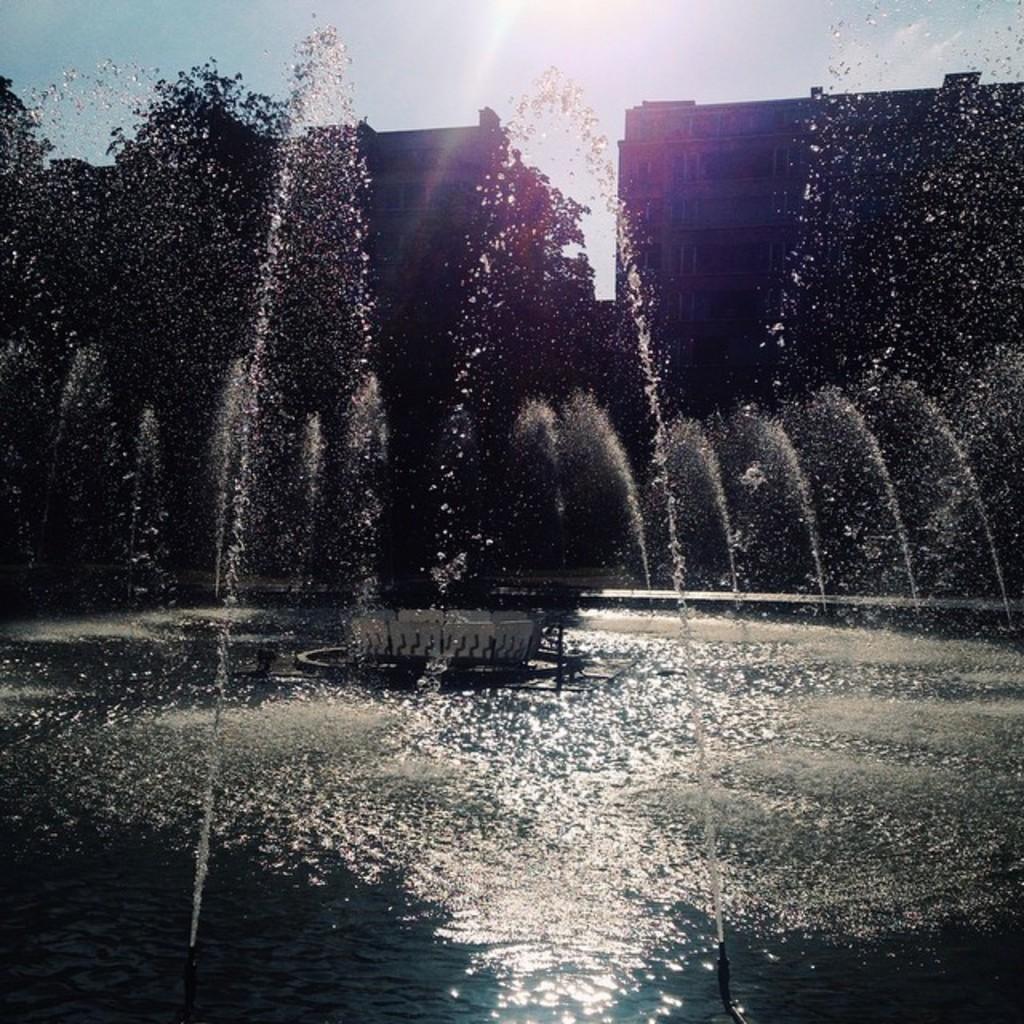Could you give a brief overview of what you see in this image? In this image there is the sky, there are buildings, there is a building truncated towards the right of the image, there is a fountain, there is water truncated towards the bottom of the image. 